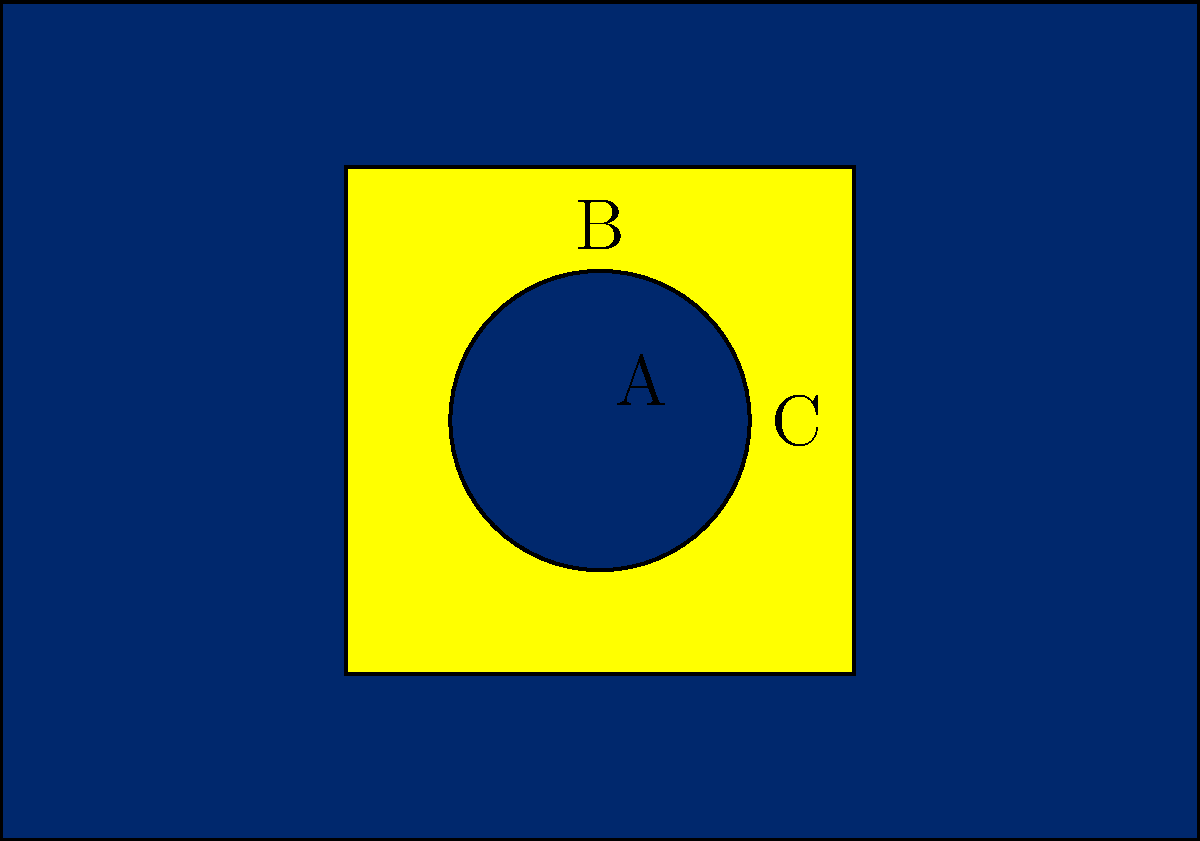In the simplified Brazilian flag design shown, the yellow rhombus is inscribed in a rectangle. If the distance from point A to point B is 12.5 units, what is the length of AC? Let's approach this step-by-step:

1) In the Brazilian flag, the yellow rhombus is actually a perfect rhombus, which means all its sides are equal.

2) The circle inscribed in the rhombus has its center at point A, which is also the center of the rhombus.

3) AB is a radius of the circle, and we're told it's 12.5 units long.

4) In a rhombus, the diagonals bisect each other at right angles. This means that AC is half of a diagonal of the rhombus.

5) In a rhombus, the diagonals are perpendicular to each other and form four congruent right triangles.

6) Triangle ABC is one of these right triangles, with AB as its height and AC as half of its base.

7) In a right triangle, we can use the Pythagorean theorem: $AC^2 + AB^2 = BC^2$

8) BC is a side of the rhombus. In a rhombus, each side is equal to the square root of the sum of the squares of half of each diagonal.

9) So, $BC^2 = (\frac{1}{2}AC)^2 + AB^2$

10) Substituting the known value: $BC^2 = (\frac{1}{2}AC)^2 + 12.5^2$

11) From steps 7 and 10: $AC^2 + 12.5^2 = (\frac{1}{2}AC)^2 + 12.5^2$

12) Simplifying: $AC^2 = (\frac{1}{2}AC)^2$

13) Taking the square root of both sides: $AC = \frac{1}{2}AC \sqrt{2}$

14) Solving for AC: $AC = 12.5\sqrt{2}$

Therefore, the length of AC is $12.5\sqrt{2}$ units.
Answer: $12.5\sqrt{2}$ units 